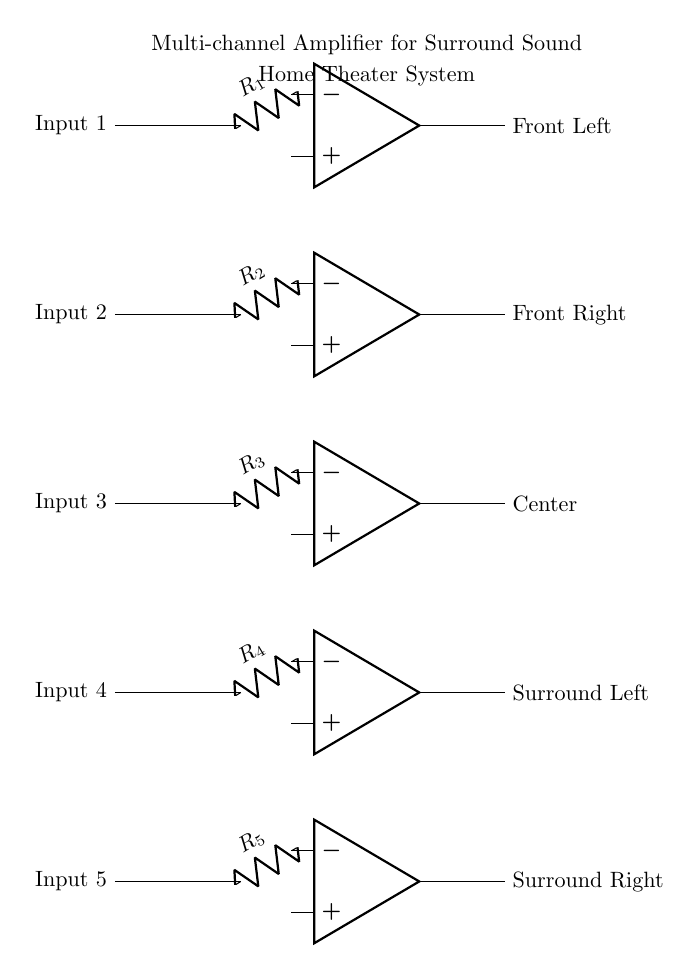What type of amplifier is represented in this circuit? This circuit diagram depicts a multi-channel amplifier specifically designed for surround sound home theater systems. The presence of multiple operational amplifiers indicates that it can handle various audio channels simultaneously.
Answer: Multi-channel amplifier How many operational amplifiers are used in this circuit? The diagram shows a total of five operational amplifiers stacked vertically, each representing a different audio channel output.
Answer: Five What are the outputs of the operational amplifiers? The outputs labeled in the diagram indicate the specific channel each amplifier drives: Front Left, Front Right, Center, Surround Left, and Surround Right. This distribution allows for full surround sound capability.
Answer: Front Left, Front Right, Center, Surround Left, Surround Right What is the role of the resistors in this circuit? The resistors, connected to each operational amplifier input, serve to limit current and define a specific gain configuration for each channel, ensuring proper amplification specific to the desired output level.
Answer: Limit current and define gain What is the primary purpose of this multi-channel amplifier? The primary purpose of this multi-channel amplifier is to amplify audio signals from multiple channels, allowing a surround sound experience in home theater systems, by ensuring each channel is boosted for optimal performance.
Answer: Amplify audio signals Which audio channel is represented at the top of the diagram? The topmost operational amplifier's output is labeled Front Left, indicating that this channel is designated for the left front speaker in the surround sound arrangement.
Answer: Front Left 